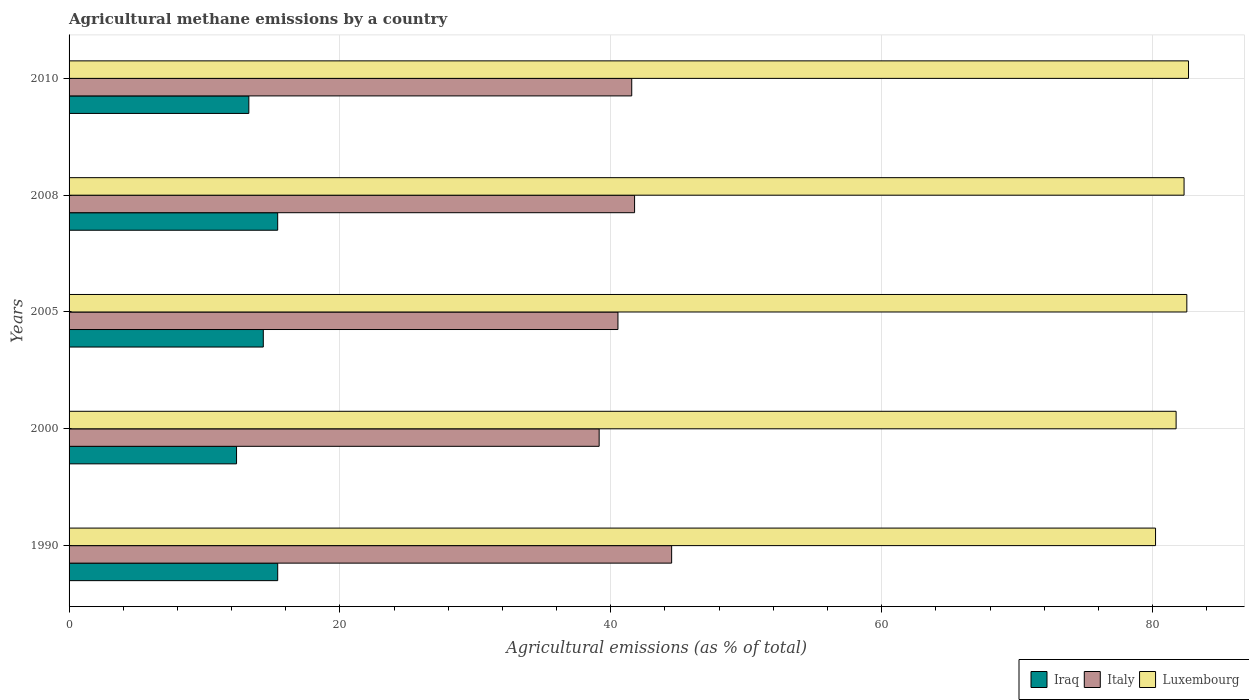How many groups of bars are there?
Offer a terse response. 5. How many bars are there on the 5th tick from the bottom?
Make the answer very short. 3. What is the label of the 4th group of bars from the top?
Provide a short and direct response. 2000. What is the amount of agricultural methane emitted in Italy in 2010?
Keep it short and to the point. 41.55. Across all years, what is the maximum amount of agricultural methane emitted in Italy?
Your answer should be very brief. 44.49. Across all years, what is the minimum amount of agricultural methane emitted in Italy?
Offer a very short reply. 39.14. In which year was the amount of agricultural methane emitted in Iraq maximum?
Offer a terse response. 1990. In which year was the amount of agricultural methane emitted in Luxembourg minimum?
Your answer should be compact. 1990. What is the total amount of agricultural methane emitted in Iraq in the graph?
Give a very brief answer. 70.79. What is the difference between the amount of agricultural methane emitted in Iraq in 2005 and that in 2010?
Your answer should be very brief. 1.07. What is the difference between the amount of agricultural methane emitted in Italy in 2010 and the amount of agricultural methane emitted in Luxembourg in 2005?
Offer a terse response. -40.99. What is the average amount of agricultural methane emitted in Italy per year?
Your answer should be compact. 41.49. In the year 2010, what is the difference between the amount of agricultural methane emitted in Italy and amount of agricultural methane emitted in Iraq?
Provide a short and direct response. 28.27. In how many years, is the amount of agricultural methane emitted in Italy greater than 56 %?
Offer a terse response. 0. What is the ratio of the amount of agricultural methane emitted in Luxembourg in 2005 to that in 2010?
Your response must be concise. 1. Is the amount of agricultural methane emitted in Italy in 2000 less than that in 2005?
Offer a terse response. Yes. Is the difference between the amount of agricultural methane emitted in Italy in 2000 and 2005 greater than the difference between the amount of agricultural methane emitted in Iraq in 2000 and 2005?
Offer a very short reply. Yes. What is the difference between the highest and the second highest amount of agricultural methane emitted in Iraq?
Offer a terse response. 0. What is the difference between the highest and the lowest amount of agricultural methane emitted in Italy?
Provide a succinct answer. 5.35. Is the sum of the amount of agricultural methane emitted in Luxembourg in 2000 and 2010 greater than the maximum amount of agricultural methane emitted in Iraq across all years?
Make the answer very short. Yes. What does the 3rd bar from the top in 2005 represents?
Make the answer very short. Iraq. What does the 3rd bar from the bottom in 1990 represents?
Keep it short and to the point. Luxembourg. Does the graph contain grids?
Your answer should be very brief. Yes. Where does the legend appear in the graph?
Your response must be concise. Bottom right. How are the legend labels stacked?
Ensure brevity in your answer.  Horizontal. What is the title of the graph?
Your response must be concise. Agricultural methane emissions by a country. What is the label or title of the X-axis?
Offer a very short reply. Agricultural emissions (as % of total). What is the Agricultural emissions (as % of total) of Iraq in 1990?
Your answer should be compact. 15.4. What is the Agricultural emissions (as % of total) in Italy in 1990?
Give a very brief answer. 44.49. What is the Agricultural emissions (as % of total) of Luxembourg in 1990?
Give a very brief answer. 80.22. What is the Agricultural emissions (as % of total) in Iraq in 2000?
Your answer should be compact. 12.37. What is the Agricultural emissions (as % of total) of Italy in 2000?
Your response must be concise. 39.14. What is the Agricultural emissions (as % of total) in Luxembourg in 2000?
Make the answer very short. 81.74. What is the Agricultural emissions (as % of total) in Iraq in 2005?
Your answer should be compact. 14.34. What is the Agricultural emissions (as % of total) of Italy in 2005?
Your response must be concise. 40.53. What is the Agricultural emissions (as % of total) in Luxembourg in 2005?
Keep it short and to the point. 82.53. What is the Agricultural emissions (as % of total) in Iraq in 2008?
Keep it short and to the point. 15.4. What is the Agricultural emissions (as % of total) of Italy in 2008?
Provide a short and direct response. 41.76. What is the Agricultural emissions (as % of total) in Luxembourg in 2008?
Keep it short and to the point. 82.33. What is the Agricultural emissions (as % of total) of Iraq in 2010?
Give a very brief answer. 13.27. What is the Agricultural emissions (as % of total) of Italy in 2010?
Give a very brief answer. 41.55. What is the Agricultural emissions (as % of total) in Luxembourg in 2010?
Your answer should be very brief. 82.66. Across all years, what is the maximum Agricultural emissions (as % of total) of Iraq?
Your response must be concise. 15.4. Across all years, what is the maximum Agricultural emissions (as % of total) in Italy?
Ensure brevity in your answer.  44.49. Across all years, what is the maximum Agricultural emissions (as % of total) of Luxembourg?
Offer a very short reply. 82.66. Across all years, what is the minimum Agricultural emissions (as % of total) in Iraq?
Offer a very short reply. 12.37. Across all years, what is the minimum Agricultural emissions (as % of total) of Italy?
Keep it short and to the point. 39.14. Across all years, what is the minimum Agricultural emissions (as % of total) in Luxembourg?
Provide a short and direct response. 80.22. What is the total Agricultural emissions (as % of total) in Iraq in the graph?
Ensure brevity in your answer.  70.79. What is the total Agricultural emissions (as % of total) in Italy in the graph?
Ensure brevity in your answer.  207.46. What is the total Agricultural emissions (as % of total) of Luxembourg in the graph?
Make the answer very short. 409.48. What is the difference between the Agricultural emissions (as % of total) of Iraq in 1990 and that in 2000?
Give a very brief answer. 3.04. What is the difference between the Agricultural emissions (as % of total) of Italy in 1990 and that in 2000?
Your response must be concise. 5.35. What is the difference between the Agricultural emissions (as % of total) in Luxembourg in 1990 and that in 2000?
Provide a short and direct response. -1.52. What is the difference between the Agricultural emissions (as % of total) of Iraq in 1990 and that in 2005?
Offer a terse response. 1.06. What is the difference between the Agricultural emissions (as % of total) of Italy in 1990 and that in 2005?
Provide a short and direct response. 3.96. What is the difference between the Agricultural emissions (as % of total) in Luxembourg in 1990 and that in 2005?
Make the answer very short. -2.31. What is the difference between the Agricultural emissions (as % of total) in Iraq in 1990 and that in 2008?
Your answer should be compact. 0. What is the difference between the Agricultural emissions (as % of total) in Italy in 1990 and that in 2008?
Ensure brevity in your answer.  2.74. What is the difference between the Agricultural emissions (as % of total) of Luxembourg in 1990 and that in 2008?
Your response must be concise. -2.11. What is the difference between the Agricultural emissions (as % of total) in Iraq in 1990 and that in 2010?
Make the answer very short. 2.13. What is the difference between the Agricultural emissions (as % of total) of Italy in 1990 and that in 2010?
Keep it short and to the point. 2.95. What is the difference between the Agricultural emissions (as % of total) of Luxembourg in 1990 and that in 2010?
Provide a succinct answer. -2.44. What is the difference between the Agricultural emissions (as % of total) of Iraq in 2000 and that in 2005?
Give a very brief answer. -1.98. What is the difference between the Agricultural emissions (as % of total) of Italy in 2000 and that in 2005?
Offer a very short reply. -1.39. What is the difference between the Agricultural emissions (as % of total) in Luxembourg in 2000 and that in 2005?
Provide a succinct answer. -0.79. What is the difference between the Agricultural emissions (as % of total) of Iraq in 2000 and that in 2008?
Give a very brief answer. -3.04. What is the difference between the Agricultural emissions (as % of total) in Italy in 2000 and that in 2008?
Offer a very short reply. -2.62. What is the difference between the Agricultural emissions (as % of total) of Luxembourg in 2000 and that in 2008?
Keep it short and to the point. -0.59. What is the difference between the Agricultural emissions (as % of total) of Iraq in 2000 and that in 2010?
Provide a succinct answer. -0.91. What is the difference between the Agricultural emissions (as % of total) in Italy in 2000 and that in 2010?
Give a very brief answer. -2.41. What is the difference between the Agricultural emissions (as % of total) in Luxembourg in 2000 and that in 2010?
Your response must be concise. -0.92. What is the difference between the Agricultural emissions (as % of total) in Iraq in 2005 and that in 2008?
Offer a very short reply. -1.06. What is the difference between the Agricultural emissions (as % of total) of Italy in 2005 and that in 2008?
Provide a succinct answer. -1.23. What is the difference between the Agricultural emissions (as % of total) of Luxembourg in 2005 and that in 2008?
Offer a very short reply. 0.2. What is the difference between the Agricultural emissions (as % of total) in Iraq in 2005 and that in 2010?
Your answer should be very brief. 1.07. What is the difference between the Agricultural emissions (as % of total) of Italy in 2005 and that in 2010?
Provide a succinct answer. -1.02. What is the difference between the Agricultural emissions (as % of total) of Luxembourg in 2005 and that in 2010?
Ensure brevity in your answer.  -0.12. What is the difference between the Agricultural emissions (as % of total) in Iraq in 2008 and that in 2010?
Ensure brevity in your answer.  2.13. What is the difference between the Agricultural emissions (as % of total) in Italy in 2008 and that in 2010?
Provide a short and direct response. 0.21. What is the difference between the Agricultural emissions (as % of total) of Luxembourg in 2008 and that in 2010?
Offer a terse response. -0.33. What is the difference between the Agricultural emissions (as % of total) in Iraq in 1990 and the Agricultural emissions (as % of total) in Italy in 2000?
Ensure brevity in your answer.  -23.74. What is the difference between the Agricultural emissions (as % of total) in Iraq in 1990 and the Agricultural emissions (as % of total) in Luxembourg in 2000?
Give a very brief answer. -66.34. What is the difference between the Agricultural emissions (as % of total) of Italy in 1990 and the Agricultural emissions (as % of total) of Luxembourg in 2000?
Your response must be concise. -37.25. What is the difference between the Agricultural emissions (as % of total) in Iraq in 1990 and the Agricultural emissions (as % of total) in Italy in 2005?
Make the answer very short. -25.12. What is the difference between the Agricultural emissions (as % of total) of Iraq in 1990 and the Agricultural emissions (as % of total) of Luxembourg in 2005?
Make the answer very short. -67.13. What is the difference between the Agricultural emissions (as % of total) of Italy in 1990 and the Agricultural emissions (as % of total) of Luxembourg in 2005?
Offer a terse response. -38.04. What is the difference between the Agricultural emissions (as % of total) in Iraq in 1990 and the Agricultural emissions (as % of total) in Italy in 2008?
Your answer should be compact. -26.35. What is the difference between the Agricultural emissions (as % of total) in Iraq in 1990 and the Agricultural emissions (as % of total) in Luxembourg in 2008?
Give a very brief answer. -66.92. What is the difference between the Agricultural emissions (as % of total) of Italy in 1990 and the Agricultural emissions (as % of total) of Luxembourg in 2008?
Give a very brief answer. -37.84. What is the difference between the Agricultural emissions (as % of total) in Iraq in 1990 and the Agricultural emissions (as % of total) in Italy in 2010?
Offer a terse response. -26.14. What is the difference between the Agricultural emissions (as % of total) of Iraq in 1990 and the Agricultural emissions (as % of total) of Luxembourg in 2010?
Your response must be concise. -67.25. What is the difference between the Agricultural emissions (as % of total) of Italy in 1990 and the Agricultural emissions (as % of total) of Luxembourg in 2010?
Your answer should be compact. -38.17. What is the difference between the Agricultural emissions (as % of total) in Iraq in 2000 and the Agricultural emissions (as % of total) in Italy in 2005?
Your response must be concise. -28.16. What is the difference between the Agricultural emissions (as % of total) of Iraq in 2000 and the Agricultural emissions (as % of total) of Luxembourg in 2005?
Ensure brevity in your answer.  -70.17. What is the difference between the Agricultural emissions (as % of total) in Italy in 2000 and the Agricultural emissions (as % of total) in Luxembourg in 2005?
Provide a short and direct response. -43.39. What is the difference between the Agricultural emissions (as % of total) in Iraq in 2000 and the Agricultural emissions (as % of total) in Italy in 2008?
Offer a terse response. -29.39. What is the difference between the Agricultural emissions (as % of total) in Iraq in 2000 and the Agricultural emissions (as % of total) in Luxembourg in 2008?
Keep it short and to the point. -69.96. What is the difference between the Agricultural emissions (as % of total) in Italy in 2000 and the Agricultural emissions (as % of total) in Luxembourg in 2008?
Provide a short and direct response. -43.19. What is the difference between the Agricultural emissions (as % of total) of Iraq in 2000 and the Agricultural emissions (as % of total) of Italy in 2010?
Your answer should be very brief. -29.18. What is the difference between the Agricultural emissions (as % of total) in Iraq in 2000 and the Agricultural emissions (as % of total) in Luxembourg in 2010?
Your response must be concise. -70.29. What is the difference between the Agricultural emissions (as % of total) in Italy in 2000 and the Agricultural emissions (as % of total) in Luxembourg in 2010?
Your response must be concise. -43.52. What is the difference between the Agricultural emissions (as % of total) of Iraq in 2005 and the Agricultural emissions (as % of total) of Italy in 2008?
Keep it short and to the point. -27.41. What is the difference between the Agricultural emissions (as % of total) in Iraq in 2005 and the Agricultural emissions (as % of total) in Luxembourg in 2008?
Provide a short and direct response. -67.99. What is the difference between the Agricultural emissions (as % of total) in Italy in 2005 and the Agricultural emissions (as % of total) in Luxembourg in 2008?
Your response must be concise. -41.8. What is the difference between the Agricultural emissions (as % of total) of Iraq in 2005 and the Agricultural emissions (as % of total) of Italy in 2010?
Ensure brevity in your answer.  -27.2. What is the difference between the Agricultural emissions (as % of total) in Iraq in 2005 and the Agricultural emissions (as % of total) in Luxembourg in 2010?
Provide a short and direct response. -68.32. What is the difference between the Agricultural emissions (as % of total) in Italy in 2005 and the Agricultural emissions (as % of total) in Luxembourg in 2010?
Provide a succinct answer. -42.13. What is the difference between the Agricultural emissions (as % of total) in Iraq in 2008 and the Agricultural emissions (as % of total) in Italy in 2010?
Provide a succinct answer. -26.14. What is the difference between the Agricultural emissions (as % of total) in Iraq in 2008 and the Agricultural emissions (as % of total) in Luxembourg in 2010?
Keep it short and to the point. -67.25. What is the difference between the Agricultural emissions (as % of total) in Italy in 2008 and the Agricultural emissions (as % of total) in Luxembourg in 2010?
Make the answer very short. -40.9. What is the average Agricultural emissions (as % of total) in Iraq per year?
Give a very brief answer. 14.16. What is the average Agricultural emissions (as % of total) in Italy per year?
Ensure brevity in your answer.  41.49. What is the average Agricultural emissions (as % of total) of Luxembourg per year?
Keep it short and to the point. 81.9. In the year 1990, what is the difference between the Agricultural emissions (as % of total) in Iraq and Agricultural emissions (as % of total) in Italy?
Make the answer very short. -29.09. In the year 1990, what is the difference between the Agricultural emissions (as % of total) of Iraq and Agricultural emissions (as % of total) of Luxembourg?
Keep it short and to the point. -64.82. In the year 1990, what is the difference between the Agricultural emissions (as % of total) of Italy and Agricultural emissions (as % of total) of Luxembourg?
Ensure brevity in your answer.  -35.73. In the year 2000, what is the difference between the Agricultural emissions (as % of total) in Iraq and Agricultural emissions (as % of total) in Italy?
Your answer should be very brief. -26.77. In the year 2000, what is the difference between the Agricultural emissions (as % of total) in Iraq and Agricultural emissions (as % of total) in Luxembourg?
Your response must be concise. -69.38. In the year 2000, what is the difference between the Agricultural emissions (as % of total) of Italy and Agricultural emissions (as % of total) of Luxembourg?
Keep it short and to the point. -42.6. In the year 2005, what is the difference between the Agricultural emissions (as % of total) of Iraq and Agricultural emissions (as % of total) of Italy?
Your answer should be compact. -26.19. In the year 2005, what is the difference between the Agricultural emissions (as % of total) in Iraq and Agricultural emissions (as % of total) in Luxembourg?
Give a very brief answer. -68.19. In the year 2005, what is the difference between the Agricultural emissions (as % of total) in Italy and Agricultural emissions (as % of total) in Luxembourg?
Keep it short and to the point. -42. In the year 2008, what is the difference between the Agricultural emissions (as % of total) of Iraq and Agricultural emissions (as % of total) of Italy?
Offer a terse response. -26.35. In the year 2008, what is the difference between the Agricultural emissions (as % of total) of Iraq and Agricultural emissions (as % of total) of Luxembourg?
Provide a succinct answer. -66.92. In the year 2008, what is the difference between the Agricultural emissions (as % of total) in Italy and Agricultural emissions (as % of total) in Luxembourg?
Provide a short and direct response. -40.57. In the year 2010, what is the difference between the Agricultural emissions (as % of total) in Iraq and Agricultural emissions (as % of total) in Italy?
Your answer should be compact. -28.27. In the year 2010, what is the difference between the Agricultural emissions (as % of total) in Iraq and Agricultural emissions (as % of total) in Luxembourg?
Provide a succinct answer. -69.38. In the year 2010, what is the difference between the Agricultural emissions (as % of total) in Italy and Agricultural emissions (as % of total) in Luxembourg?
Provide a succinct answer. -41.11. What is the ratio of the Agricultural emissions (as % of total) of Iraq in 1990 to that in 2000?
Provide a short and direct response. 1.25. What is the ratio of the Agricultural emissions (as % of total) of Italy in 1990 to that in 2000?
Your response must be concise. 1.14. What is the ratio of the Agricultural emissions (as % of total) in Luxembourg in 1990 to that in 2000?
Provide a succinct answer. 0.98. What is the ratio of the Agricultural emissions (as % of total) of Iraq in 1990 to that in 2005?
Offer a terse response. 1.07. What is the ratio of the Agricultural emissions (as % of total) of Italy in 1990 to that in 2005?
Offer a very short reply. 1.1. What is the ratio of the Agricultural emissions (as % of total) in Luxembourg in 1990 to that in 2005?
Offer a very short reply. 0.97. What is the ratio of the Agricultural emissions (as % of total) of Italy in 1990 to that in 2008?
Your answer should be compact. 1.07. What is the ratio of the Agricultural emissions (as % of total) in Luxembourg in 1990 to that in 2008?
Offer a very short reply. 0.97. What is the ratio of the Agricultural emissions (as % of total) of Iraq in 1990 to that in 2010?
Offer a terse response. 1.16. What is the ratio of the Agricultural emissions (as % of total) in Italy in 1990 to that in 2010?
Offer a terse response. 1.07. What is the ratio of the Agricultural emissions (as % of total) of Luxembourg in 1990 to that in 2010?
Provide a short and direct response. 0.97. What is the ratio of the Agricultural emissions (as % of total) of Iraq in 2000 to that in 2005?
Your answer should be very brief. 0.86. What is the ratio of the Agricultural emissions (as % of total) in Italy in 2000 to that in 2005?
Offer a very short reply. 0.97. What is the ratio of the Agricultural emissions (as % of total) of Iraq in 2000 to that in 2008?
Provide a succinct answer. 0.8. What is the ratio of the Agricultural emissions (as % of total) of Italy in 2000 to that in 2008?
Make the answer very short. 0.94. What is the ratio of the Agricultural emissions (as % of total) of Iraq in 2000 to that in 2010?
Offer a terse response. 0.93. What is the ratio of the Agricultural emissions (as % of total) in Italy in 2000 to that in 2010?
Give a very brief answer. 0.94. What is the ratio of the Agricultural emissions (as % of total) of Luxembourg in 2000 to that in 2010?
Make the answer very short. 0.99. What is the ratio of the Agricultural emissions (as % of total) of Italy in 2005 to that in 2008?
Offer a terse response. 0.97. What is the ratio of the Agricultural emissions (as % of total) in Luxembourg in 2005 to that in 2008?
Provide a succinct answer. 1. What is the ratio of the Agricultural emissions (as % of total) in Iraq in 2005 to that in 2010?
Give a very brief answer. 1.08. What is the ratio of the Agricultural emissions (as % of total) in Italy in 2005 to that in 2010?
Make the answer very short. 0.98. What is the ratio of the Agricultural emissions (as % of total) of Luxembourg in 2005 to that in 2010?
Keep it short and to the point. 1. What is the ratio of the Agricultural emissions (as % of total) in Iraq in 2008 to that in 2010?
Provide a short and direct response. 1.16. What is the ratio of the Agricultural emissions (as % of total) of Italy in 2008 to that in 2010?
Offer a very short reply. 1. What is the ratio of the Agricultural emissions (as % of total) of Luxembourg in 2008 to that in 2010?
Give a very brief answer. 1. What is the difference between the highest and the second highest Agricultural emissions (as % of total) of Iraq?
Keep it short and to the point. 0. What is the difference between the highest and the second highest Agricultural emissions (as % of total) of Italy?
Give a very brief answer. 2.74. What is the difference between the highest and the second highest Agricultural emissions (as % of total) in Luxembourg?
Provide a short and direct response. 0.12. What is the difference between the highest and the lowest Agricultural emissions (as % of total) of Iraq?
Offer a terse response. 3.04. What is the difference between the highest and the lowest Agricultural emissions (as % of total) of Italy?
Your answer should be compact. 5.35. What is the difference between the highest and the lowest Agricultural emissions (as % of total) of Luxembourg?
Your response must be concise. 2.44. 